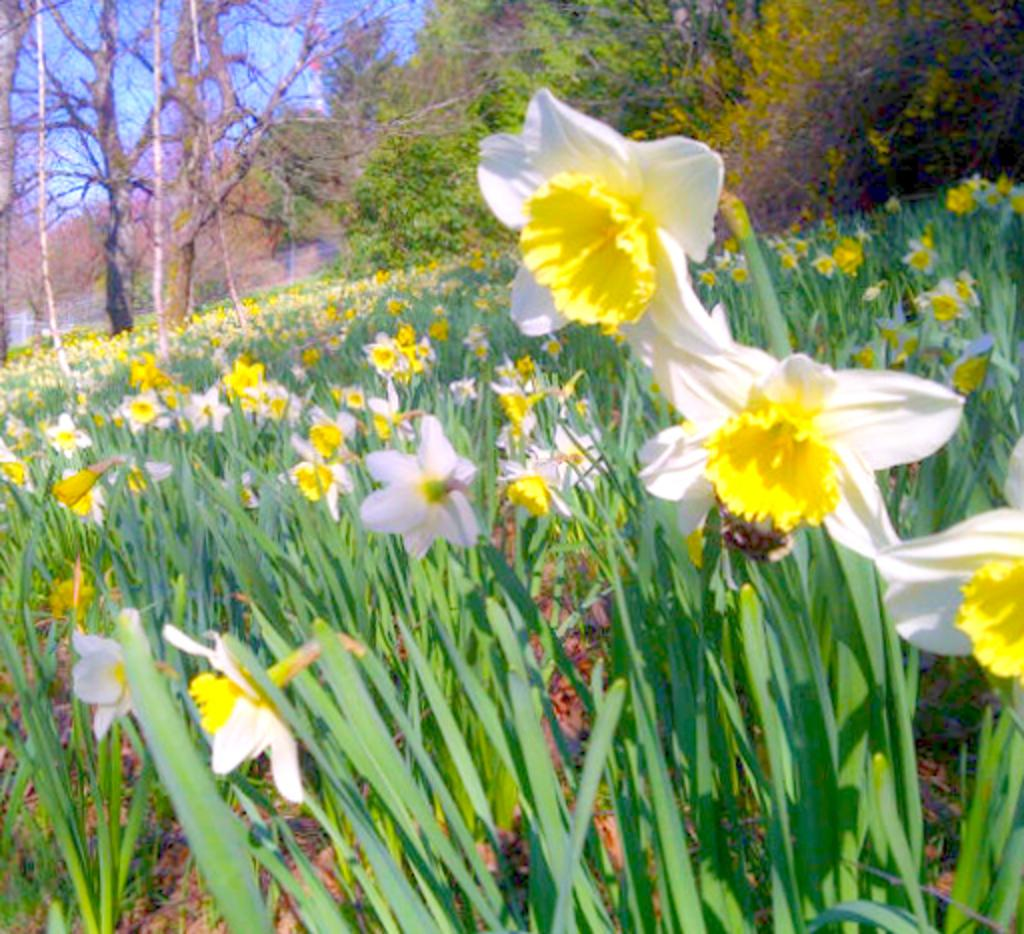What type of plants can be seen in the image? There are plants with flowers in the image. What can be seen in the background of the image? There are trees in the background of the image. What type of pancake is being served to the spy in the image? There is no pancake or spy present in the image; it features plants with flowers and trees in the background. 